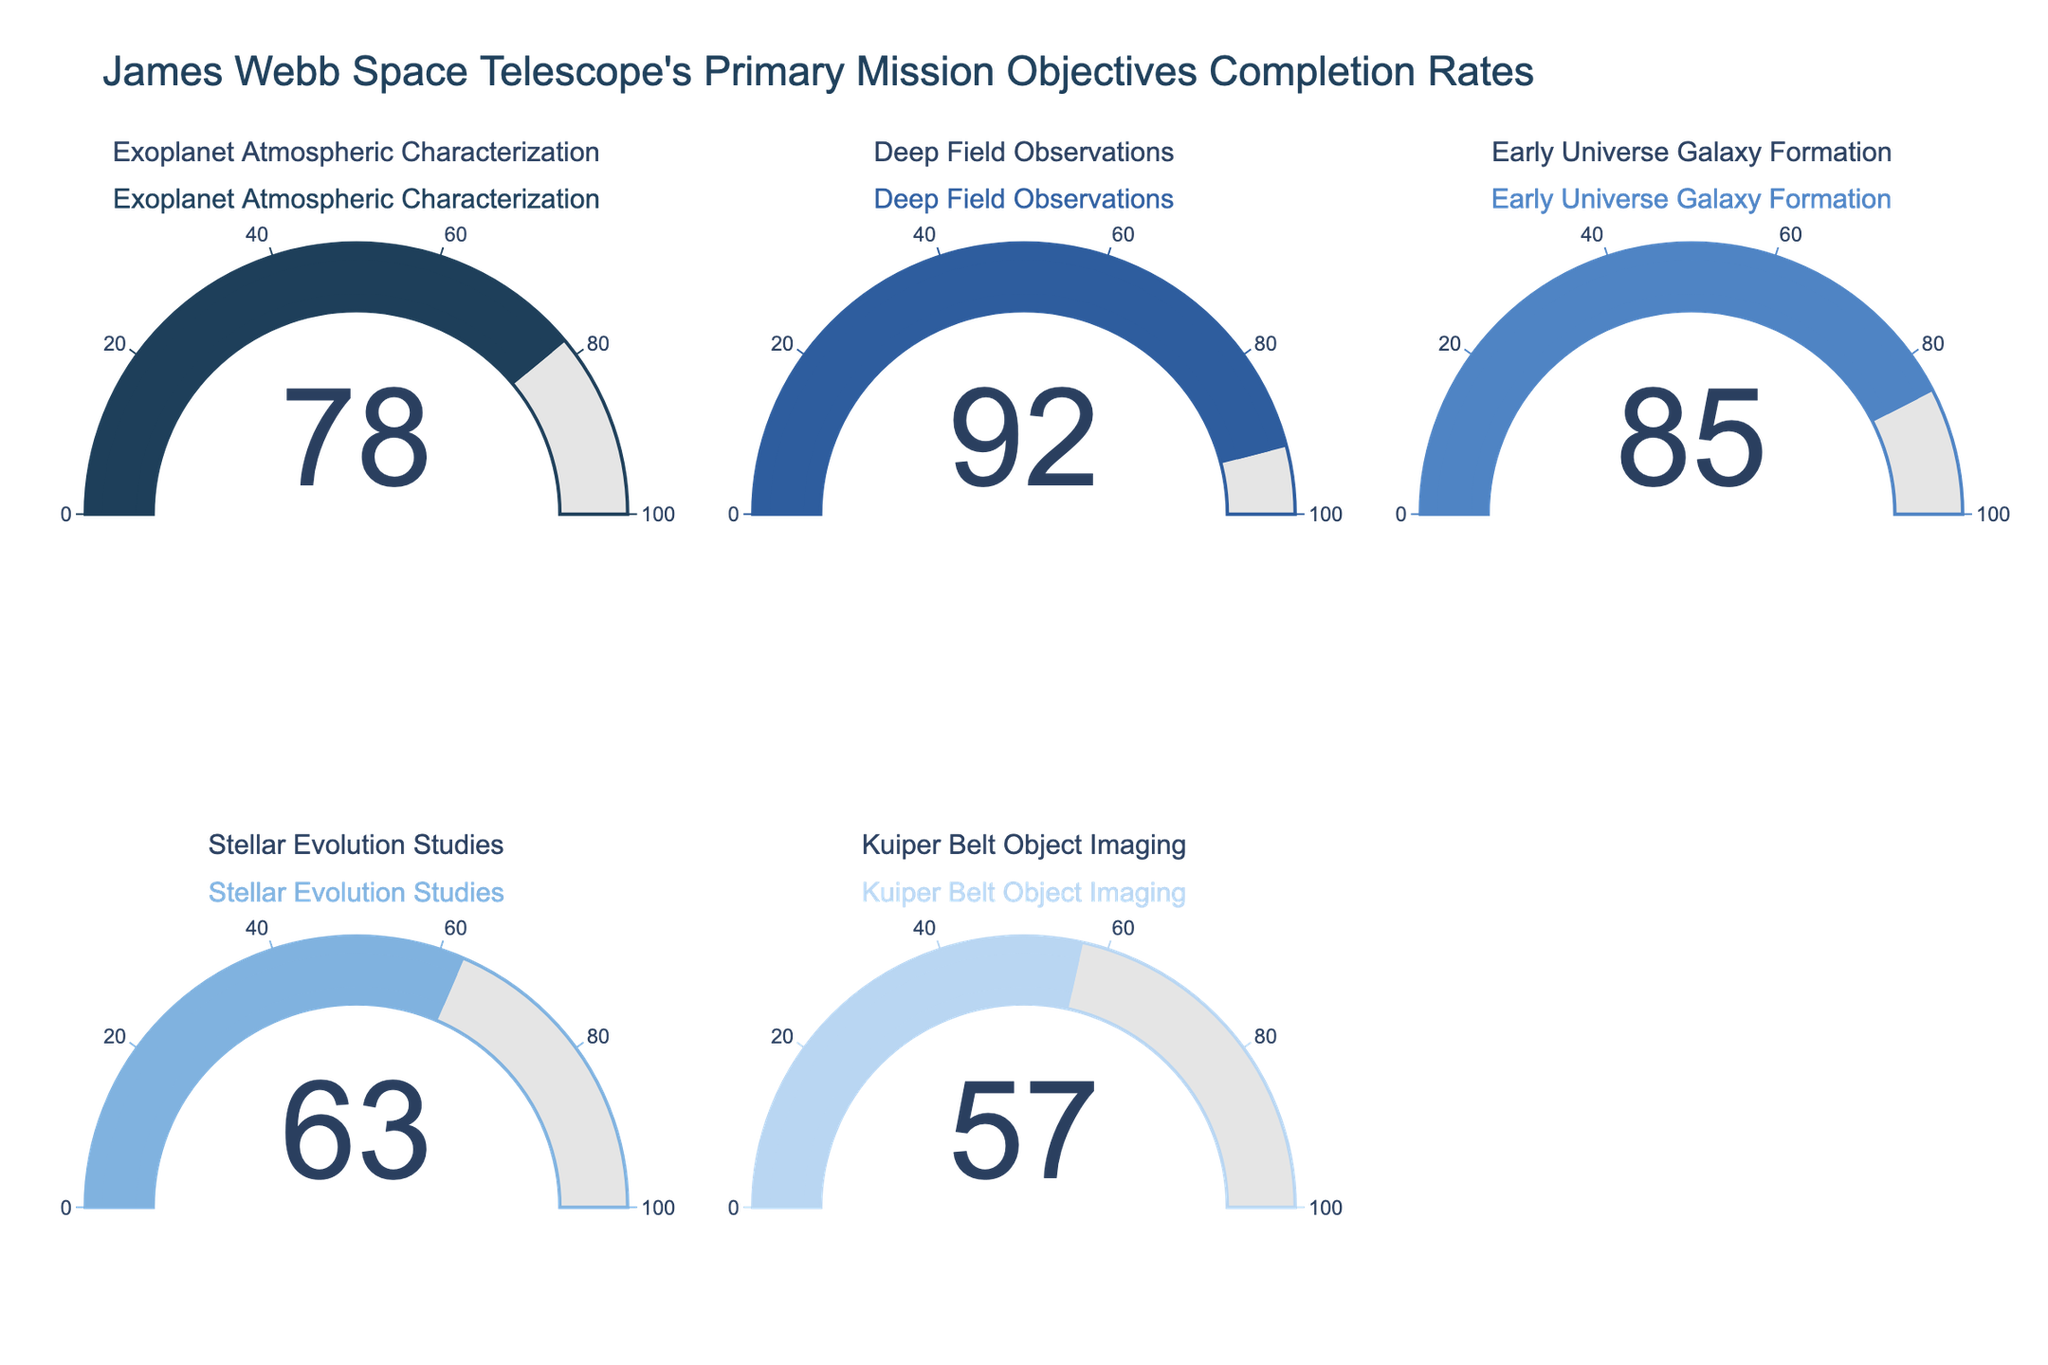what is the completion rate of Exoplanet Atmospheric Characterization? Look at the gauge chart labeled "Exoplanet Atmospheric Characterization". The number within the gauge represents the completion rate.
Answer: 78 Which mission objective has the lowest completion rate? Compare the values in all five gauges and find the smallest number. The lowest value is the completion rate of the mission objective "Kuiper Belt Object Imaging".
Answer: Kuiper Belt Object Imaging What is the total completion rate for Early Universe Galaxy Formation and Deep Field Observations? Find the completion rates for Early Universe Galaxy Formation (85) and Deep Field Observations (92), then add these two values together. 85 + 92 = 177.
Answer: 177 How does the completion rate of Stellar Evolution Studies compare to Exoplanet Atmospheric Characterization? Compare the values of Stellar Evolution Studies (63) and Exoplanet Atmospheric Characterization (78). The completion rate for Stellar Evolution Studies is less than Exoplanet Atmospheric Characterization.
Answer: Less Which mission objective's completion rate is closest to 80? Compare the completion rates of each mission objective to 80. The one closest to 80 is "Exoplanet Atmospheric Characterization" with a value of 78.
Answer: Exoplanet Atmospheric Characterization What is the average completion rate of all mission objectives? Add all completion rates together and divide by the number of mission objectives: (78 + 92 + 85 + 63 + 57) / 5 = 75
Answer: 75 How many mission objectives have a completion rate greater than 70? Count the number of mission objectives with completion rates above 70. There are 3 such objectives: Exoplanet Atmospheric Characterization (78), Deep Field Observations (92), and Early Universe Galaxy Formation (85).
Answer: 3 Is the completion rate of Kuiper Belt Object Imaging greater than Stellar Evolution Studies? Compare the values of Kuiper Belt Object Imaging (57) and Stellar Evolution Studies (63). The completion rate for Kuiper Belt Object Imaging is less than Stellar Evolution Studies.
Answer: No Which mission objective has a completion rate greater than 60 but less than 80? Locate the completion rates of all mission objectives within the specified range (60 < x < 80). "Exoplanet Atmospheric Characterization" and "Stellar Evolution Studies" fit this criterion.
Answer: Exoplanet Atmospheric Characterization, Stellar Evolution Studies 